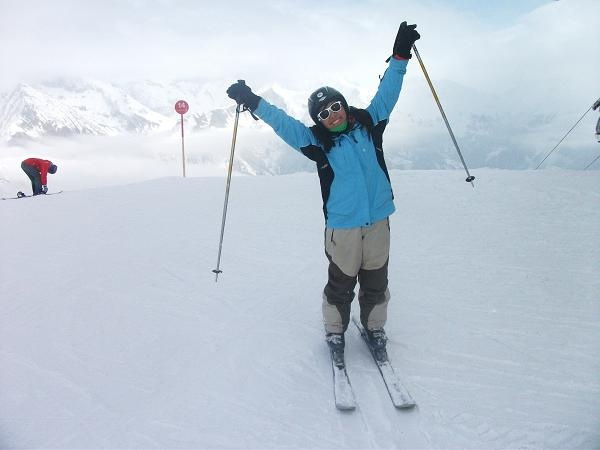Describe the objects in this image and their specific colors. I can see people in lavender, black, teal, and gray tones, skis in lavender, darkgray, lightgray, and gray tones, people in lavender, gray, brown, and black tones, people in lavender, gray, darkgray, and lightgray tones, and skis in lavender, gray, and darkgray tones in this image. 